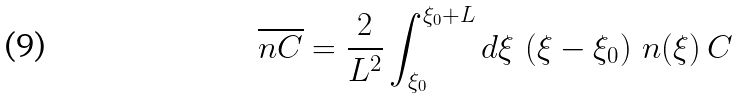Convert formula to latex. <formula><loc_0><loc_0><loc_500><loc_500>\overline { n C } = \frac { 2 } { L ^ { 2 } } \int _ { \xi _ { 0 } } ^ { \xi _ { 0 } + L } d \xi \, \left ( \xi - \xi _ { 0 } \right ) \, n ( \xi ) \, C</formula> 